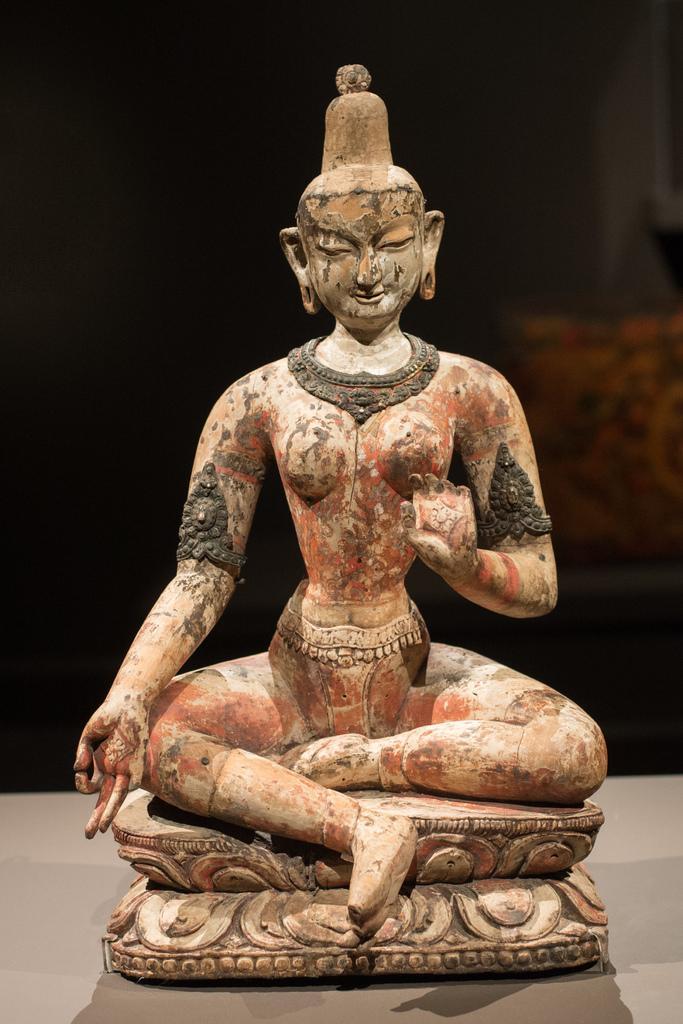How would you summarize this image in a sentence or two? In this image I can see a statue on the brown color surface. Background is in black color. 